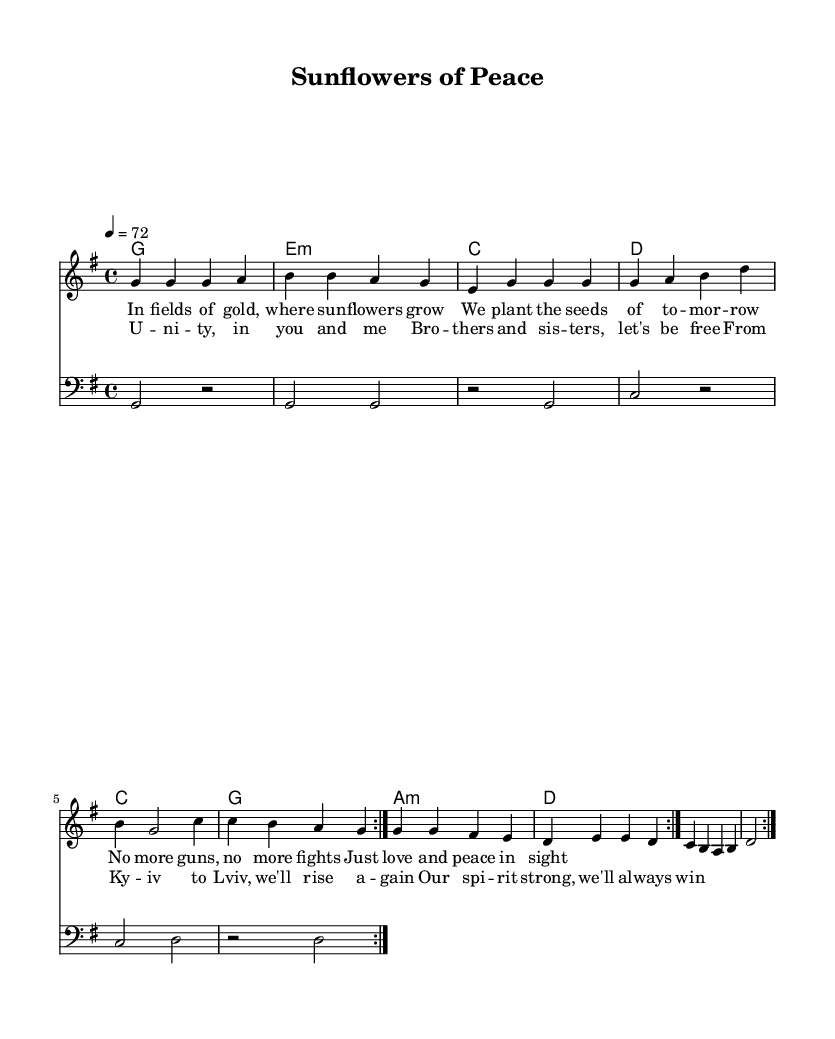What is the key signature of this music? The key signature is identified by the sharps or flats at the beginning of the staff. In this case, there are no accidentals, indicating it is in G major, which has one sharp.
Answer: G major What is the time signature of this composition? The time signature is determined by the two numbers at the beginning of the staff, representing beats per measure and note value. Here, it shows 4 over 4, indicating four beats per measure, with the quarter note receiving one beat.
Answer: 4/4 What is the tempo marking of this piece? The tempo marking is indicated by the number and note value, which shows how fast the piece should be played. In this sheet, it says "4 = 72," meaning that there are 72 quarter note beats per minute.
Answer: 72 How many measures are in the melody? To find the number of measures, count the segments separated by bar lines in the melody part of the score. There are four measures within each volta repeat, and since there are two repeats, this totals eight measures.
Answer: Eight What is the theme of the lyrics in the chorus? The lyrics can be analyzed for their subject matter. The chorus emphasizes unity, freedom, and resilience, reflecting a hopeful perspective in post-war times.
Answer: Unity Which musical style is this piece? The characteristics of reggae include its offbeat rhythm and themes of peace and unity. The title "Sunflowers of Peace" and the lyrical content suggest it aligns with reggae's style and message.
Answer: Reggae 